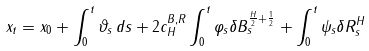Convert formula to latex. <formula><loc_0><loc_0><loc_500><loc_500>x _ { t } = x _ { 0 } + \int _ { 0 } ^ { t } \vartheta _ { s } \, d { s } + 2 c _ { H } ^ { B , R } \int _ { 0 } ^ { t } \varphi _ { s } \delta B _ { s } ^ { \frac { H } { 2 } + \frac { 1 } { 2 } } + \int _ { 0 } ^ { t } \psi _ { s } \delta R _ { s } ^ { H }</formula> 